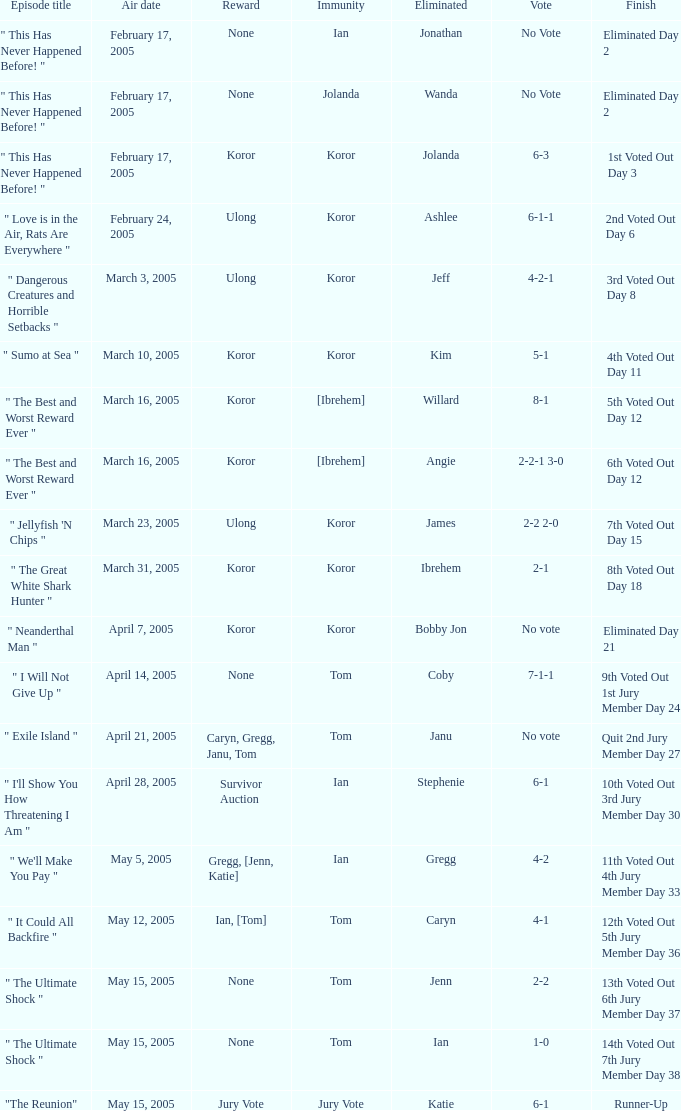Who received the reward on the episode where the finish was "3rd voted out day 8"? Ulong. 